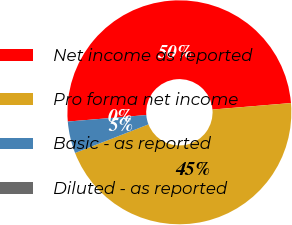Convert chart to OTSL. <chart><loc_0><loc_0><loc_500><loc_500><pie_chart><fcel>Net income as reported<fcel>Pro forma net income<fcel>Basic - as reported<fcel>Diluted - as reported<nl><fcel>50.0%<fcel>45.4%<fcel>4.6%<fcel>0.0%<nl></chart> 